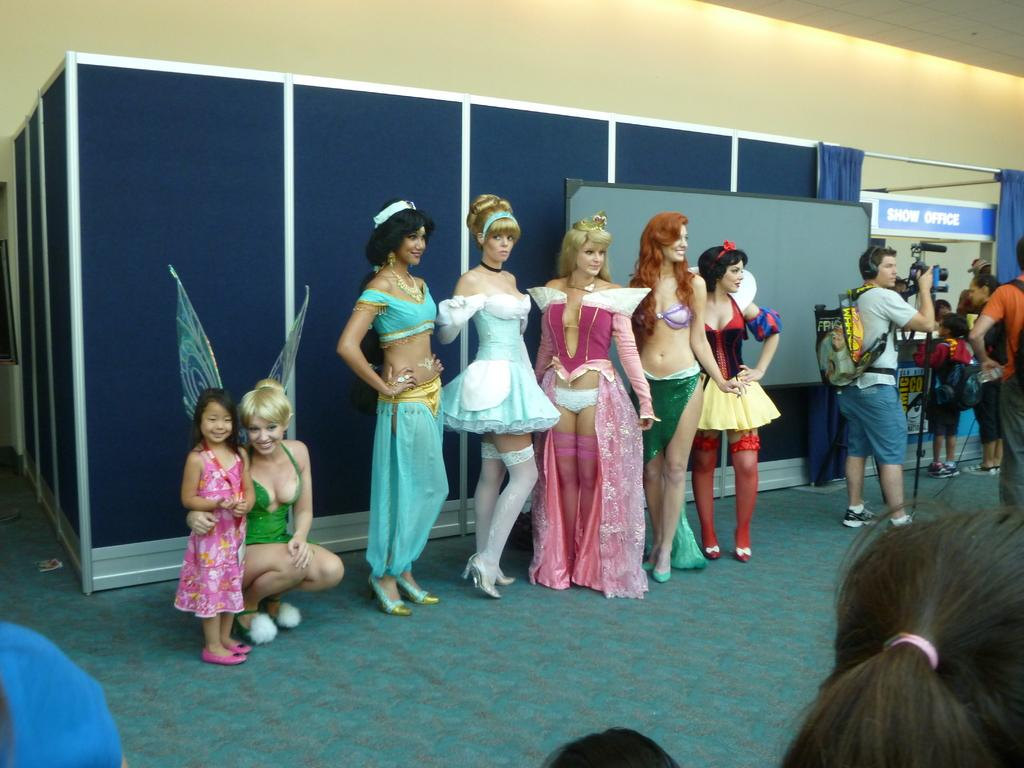What can be seen in the image regarding the people present? There are women standing in the image. How are the women dressed in the image? The women are wearing fancy dresses. What is one of the background elements in the image? There is a wall in the image. What color are the boards visible in the image? The boards are blue in color. What is covering the floor in the image? There is a carpet on the floor. How many chairs are placed around the rose in the image? There is no rose or chairs present in the image. 